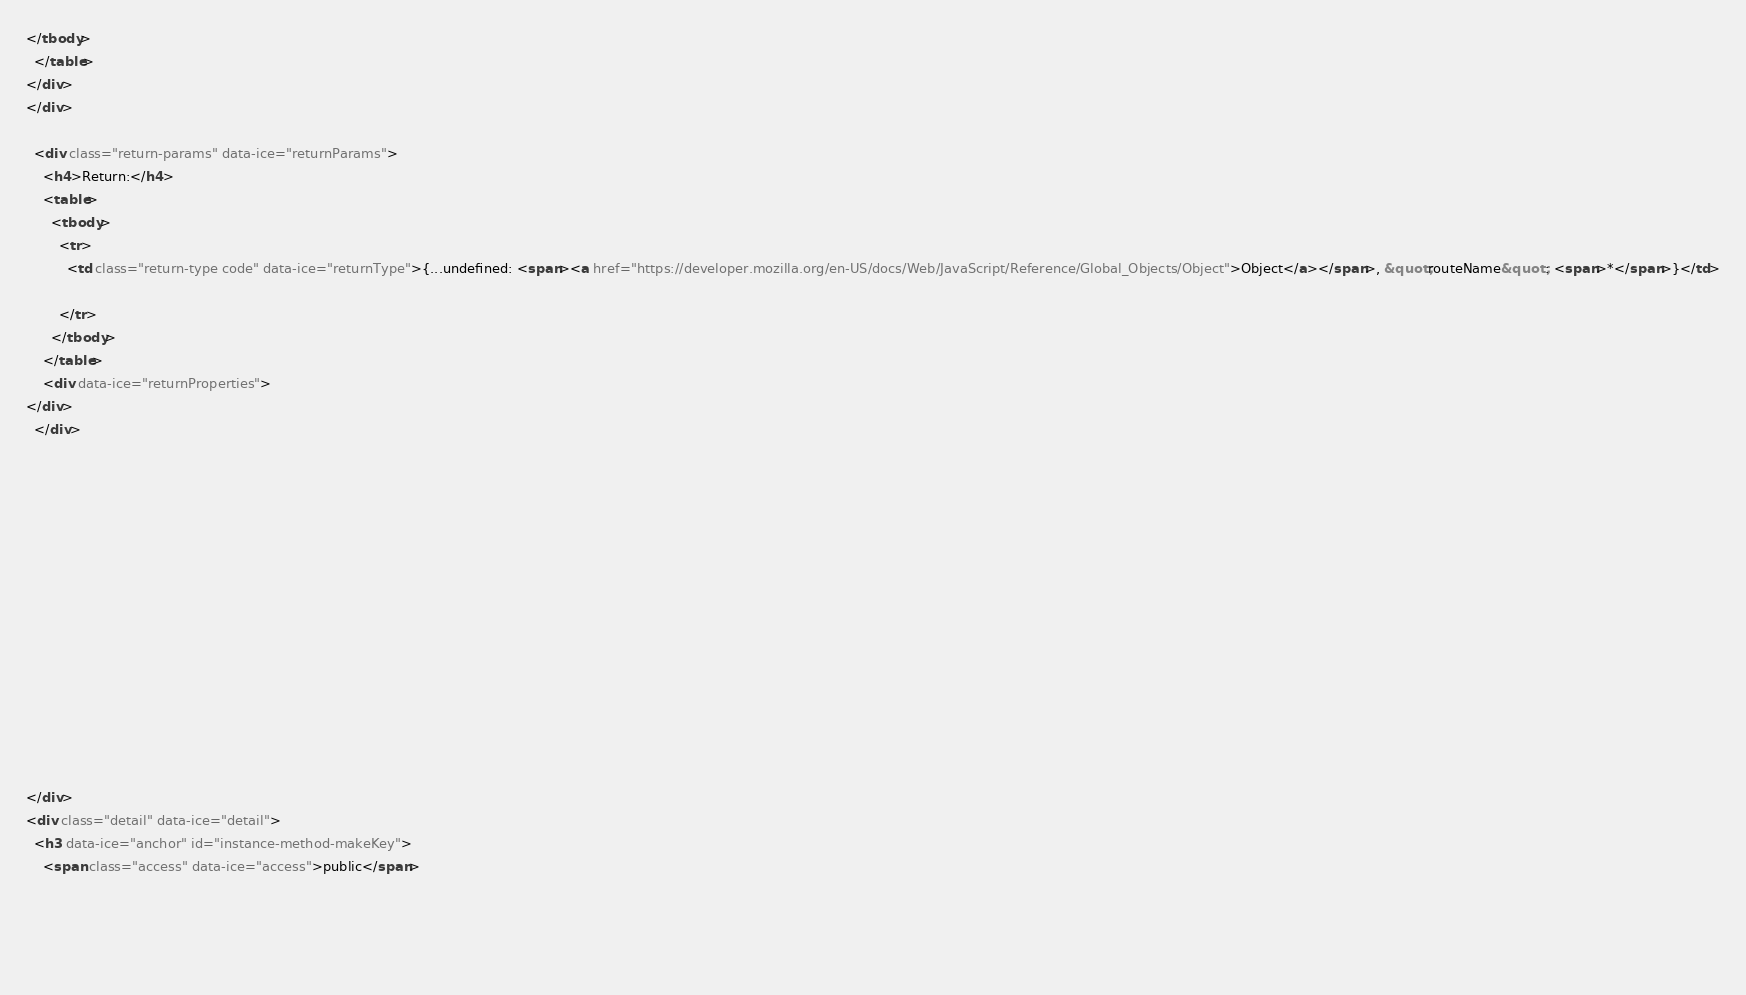<code> <loc_0><loc_0><loc_500><loc_500><_HTML_></tbody>
  </table>
</div>
</div>

  <div class="return-params" data-ice="returnParams">
    <h4>Return:</h4>
    <table>
      <tbody>
        <tr>
          <td class="return-type code" data-ice="returnType">{...undefined: <span><a href="https://developer.mozilla.org/en-US/docs/Web/JavaScript/Reference/Global_Objects/Object">Object</a></span>, &quot;routeName&quot;: <span>*</span>}</td>
          
        </tr>
      </tbody>
    </table>
    <div data-ice="returnProperties">
</div>
  </div>

  

  

  

  

  

  

  
  
</div>
<div class="detail" data-ice="detail">
  <h3 data-ice="anchor" id="instance-method-makeKey">
    <span class="access" data-ice="access">public</span>
    
    
    
    </code> 